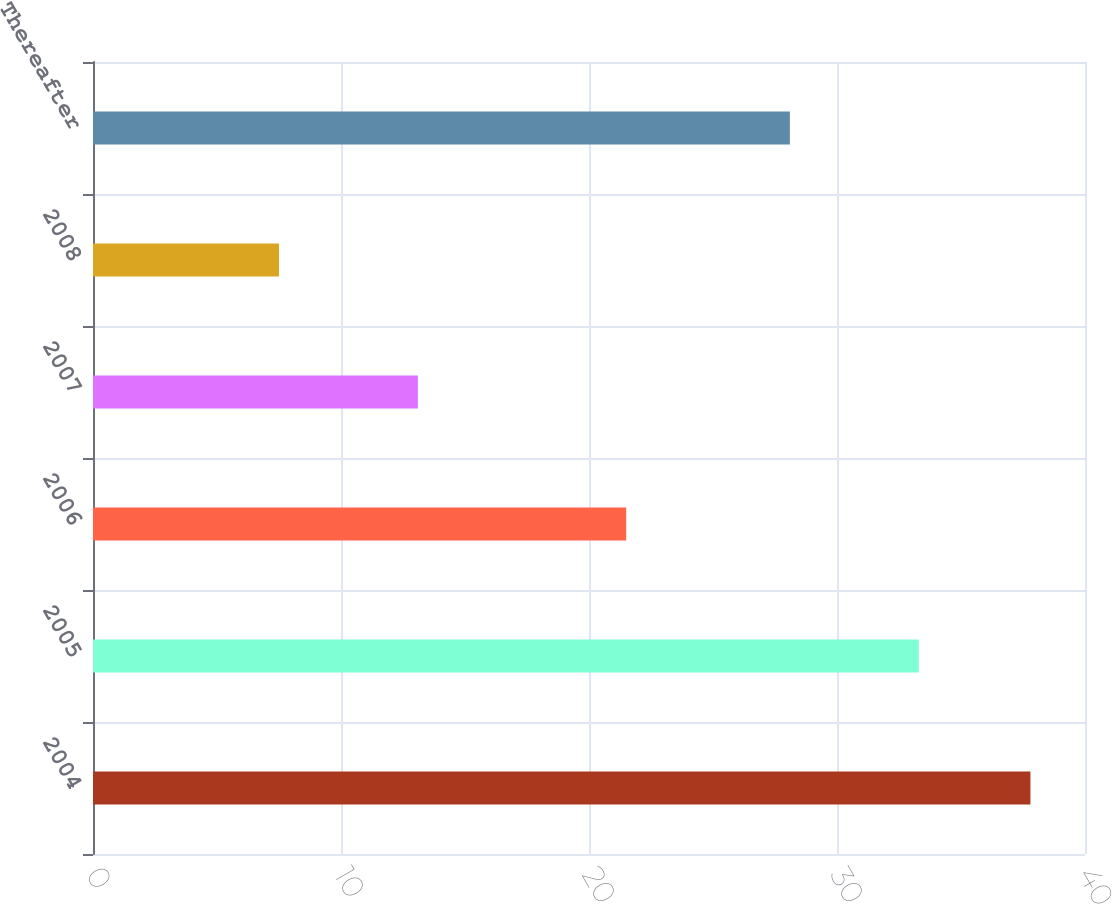<chart> <loc_0><loc_0><loc_500><loc_500><bar_chart><fcel>2004<fcel>2005<fcel>2006<fcel>2007<fcel>2008<fcel>Thereafter<nl><fcel>37.8<fcel>33.3<fcel>21.5<fcel>13.1<fcel>7.5<fcel>28.1<nl></chart> 